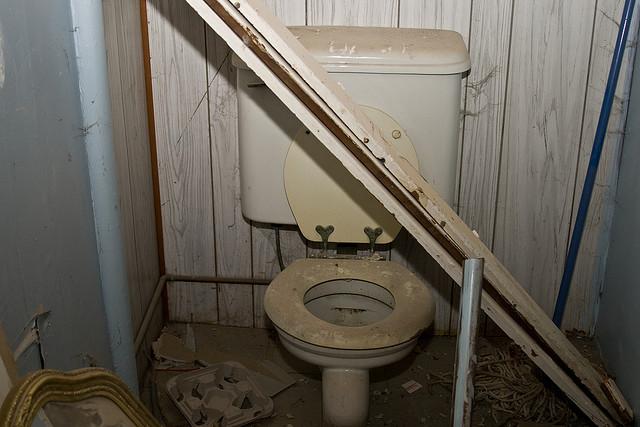Is this bathroom under construction?
Be succinct. Yes. What is leaning on the toilet?
Keep it brief. Wood. Is there any sink in the toilet?
Give a very brief answer. No. 